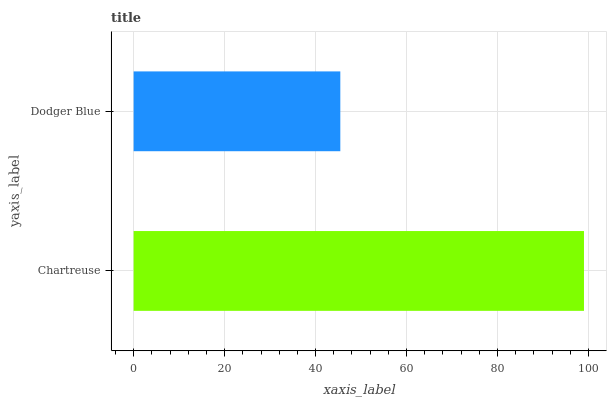Is Dodger Blue the minimum?
Answer yes or no. Yes. Is Chartreuse the maximum?
Answer yes or no. Yes. Is Dodger Blue the maximum?
Answer yes or no. No. Is Chartreuse greater than Dodger Blue?
Answer yes or no. Yes. Is Dodger Blue less than Chartreuse?
Answer yes or no. Yes. Is Dodger Blue greater than Chartreuse?
Answer yes or no. No. Is Chartreuse less than Dodger Blue?
Answer yes or no. No. Is Chartreuse the high median?
Answer yes or no. Yes. Is Dodger Blue the low median?
Answer yes or no. Yes. Is Dodger Blue the high median?
Answer yes or no. No. Is Chartreuse the low median?
Answer yes or no. No. 